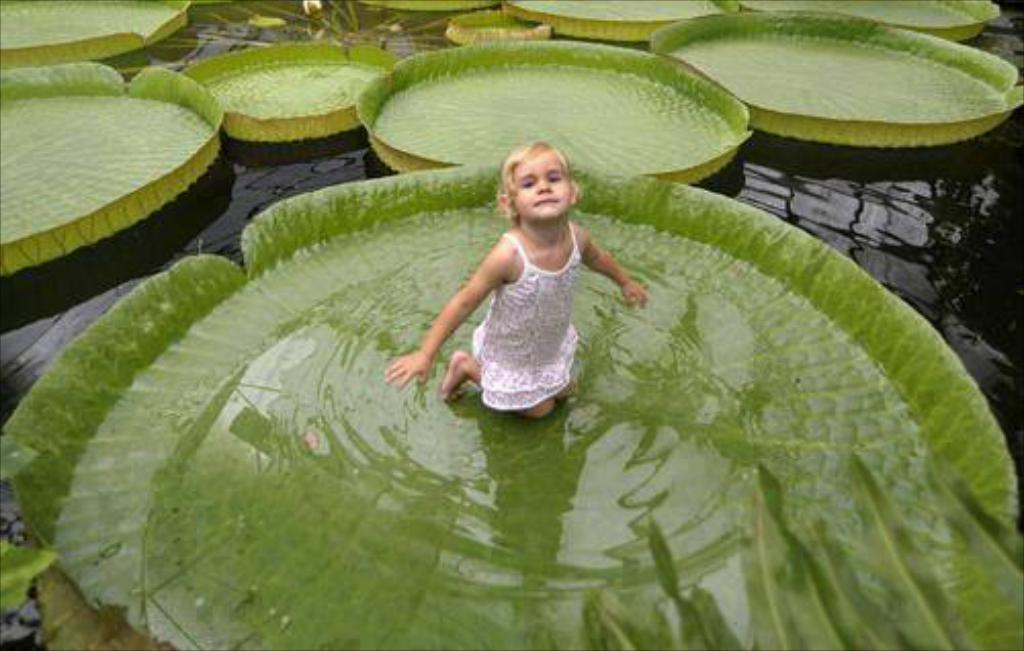Who is the main subject in the image? There is a girl in the image. What is the girl doing or where is she located? The girl is on a leaf in the image. What is the condition of the leaf? There is water on the leaf. What can be seen in the background of the image? There are leaves visible in the water in the background. What type of quartz can be seen on the girl's legs in the image? There is no quartz present in the image, and the girl's legs are not mentioned in the provided facts. 